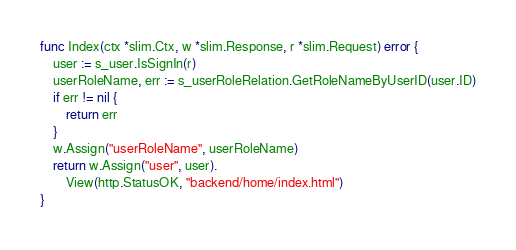Convert code to text. <code><loc_0><loc_0><loc_500><loc_500><_Go_>
func Index(ctx *slim.Ctx, w *slim.Response, r *slim.Request) error {
	user := s_user.IsSignIn(r)
	userRoleName, err := s_userRoleRelation.GetRoleNameByUserID(user.ID)
	if err != nil {
		return err
	}
	w.Assign("userRoleName", userRoleName)
	return w.Assign("user", user).
		View(http.StatusOK, "backend/home/index.html")
}
</code> 